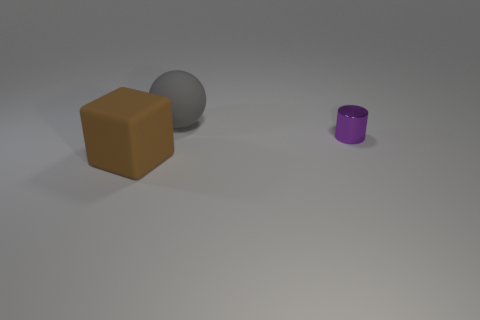There is a matte thing behind the big brown rubber cube; how big is it?
Provide a succinct answer. Large. What material is the tiny cylinder?
Make the answer very short. Metal. Is the shape of the rubber thing in front of the small purple thing the same as  the shiny object?
Make the answer very short. No. Are there any purple cylinders of the same size as the brown matte object?
Offer a very short reply. No. There is a rubber object behind the matte thing left of the ball; is there a big brown cube behind it?
Offer a very short reply. No. There is a cube; is it the same color as the big object behind the big matte cube?
Make the answer very short. No. The big thing that is to the right of the rubber object that is in front of the large object behind the small cylinder is made of what material?
Your answer should be very brief. Rubber. What shape is the rubber object to the left of the gray object?
Give a very brief answer. Cube. There is a object that is made of the same material as the gray sphere; what is its size?
Offer a terse response. Large. Is the color of the large object that is on the right side of the brown cube the same as the cube?
Your answer should be very brief. No. 